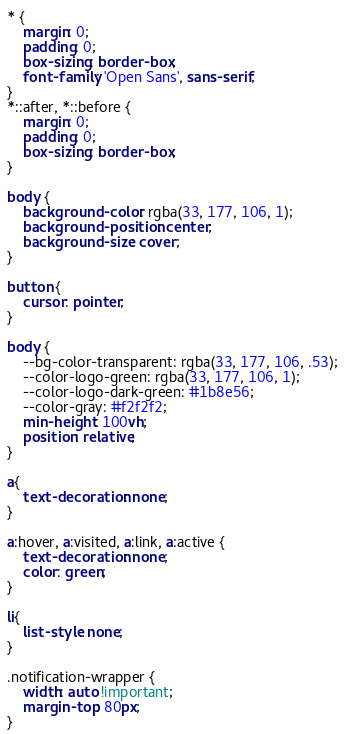Convert code to text. <code><loc_0><loc_0><loc_500><loc_500><_CSS_>* {
    margin: 0;
    padding: 0;
    box-sizing: border-box;
    font-family: 'Open Sans', sans-serif;
}
*::after, *::before {
    margin: 0;
    padding: 0;
    box-sizing: border-box;
}

body {
    background-color: rgba(33, 177, 106, 1);
    background-position: center;
    background-size: cover;
}

button {
    cursor: pointer;
}

body {
    --bg-color-transparent: rgba(33, 177, 106, .53);
    --color-logo-green: rgba(33, 177, 106, 1);
    --color-logo-dark-green: #1b8e56;
    --color-gray: #f2f2f2;
    min-height: 100vh;
    position: relative;
}

a{
    text-decoration: none;
}

a:hover, a:visited, a:link, a:active {
    text-decoration: none;
    color: green;
}

li{
    list-style: none;
}

.notification-wrapper {
    width: auto !important;
    margin-top: 80px;
}</code> 